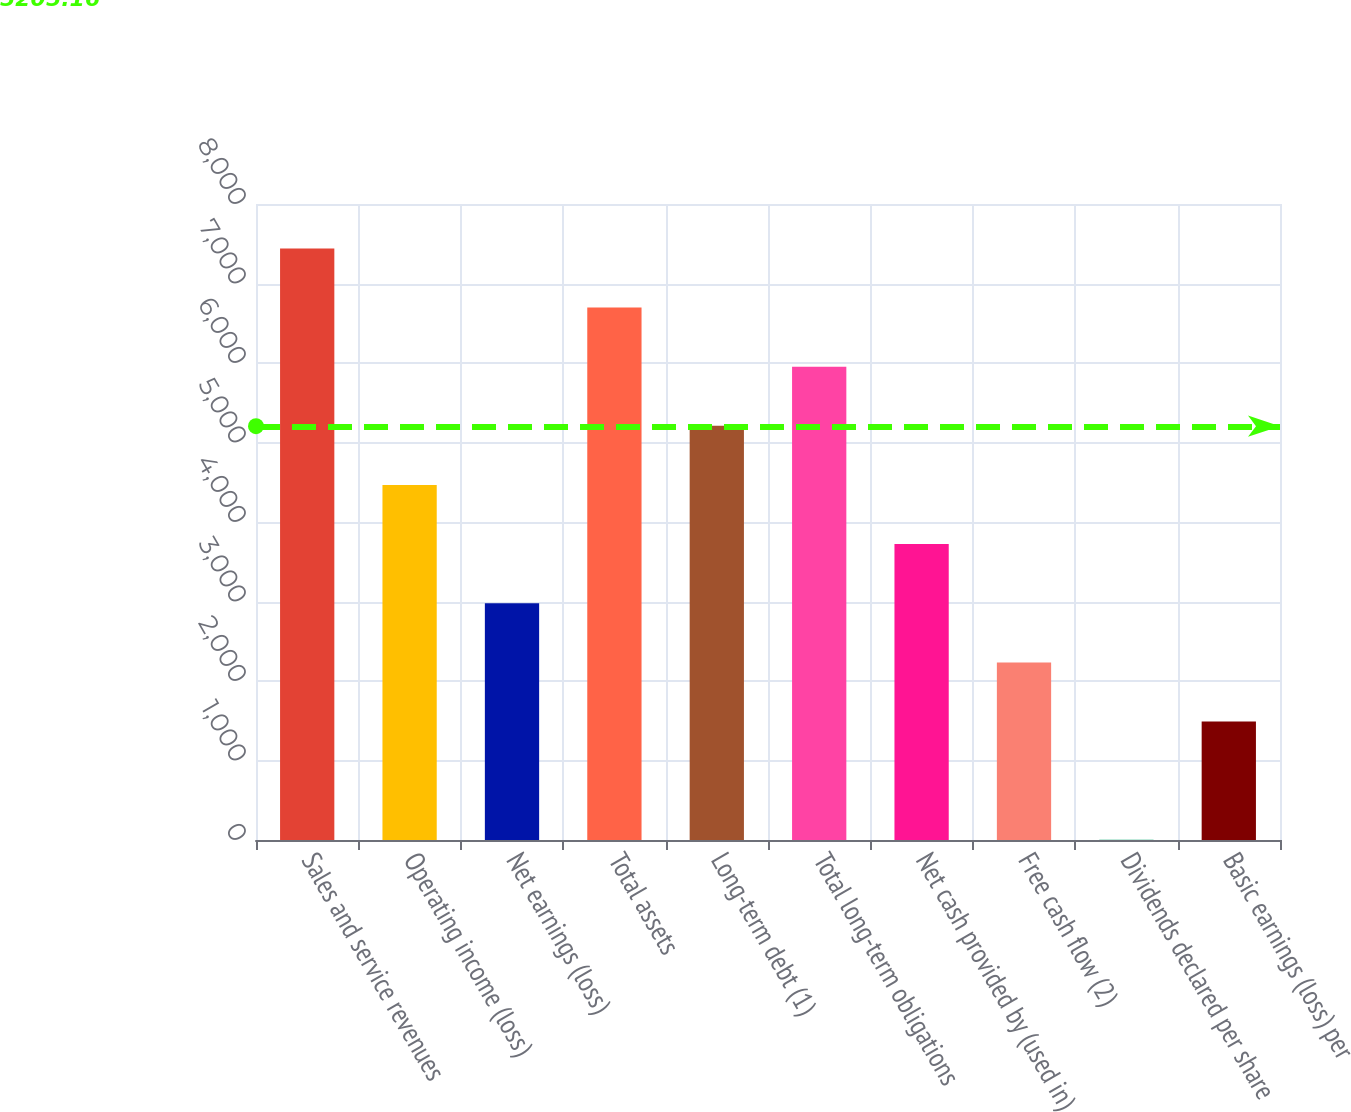<chart> <loc_0><loc_0><loc_500><loc_500><bar_chart><fcel>Sales and service revenues<fcel>Operating income (loss)<fcel>Net earnings (loss)<fcel>Total assets<fcel>Long-term debt (1)<fcel>Total long-term obligations<fcel>Net cash provided by (used in)<fcel>Free cash flow (2)<fcel>Dividends declared per share<fcel>Basic earnings (loss) per<nl><fcel>7441.02<fcel>4465.62<fcel>2977.92<fcel>6697.17<fcel>5209.47<fcel>5953.32<fcel>3721.77<fcel>2234.07<fcel>2.52<fcel>1490.22<nl></chart> 